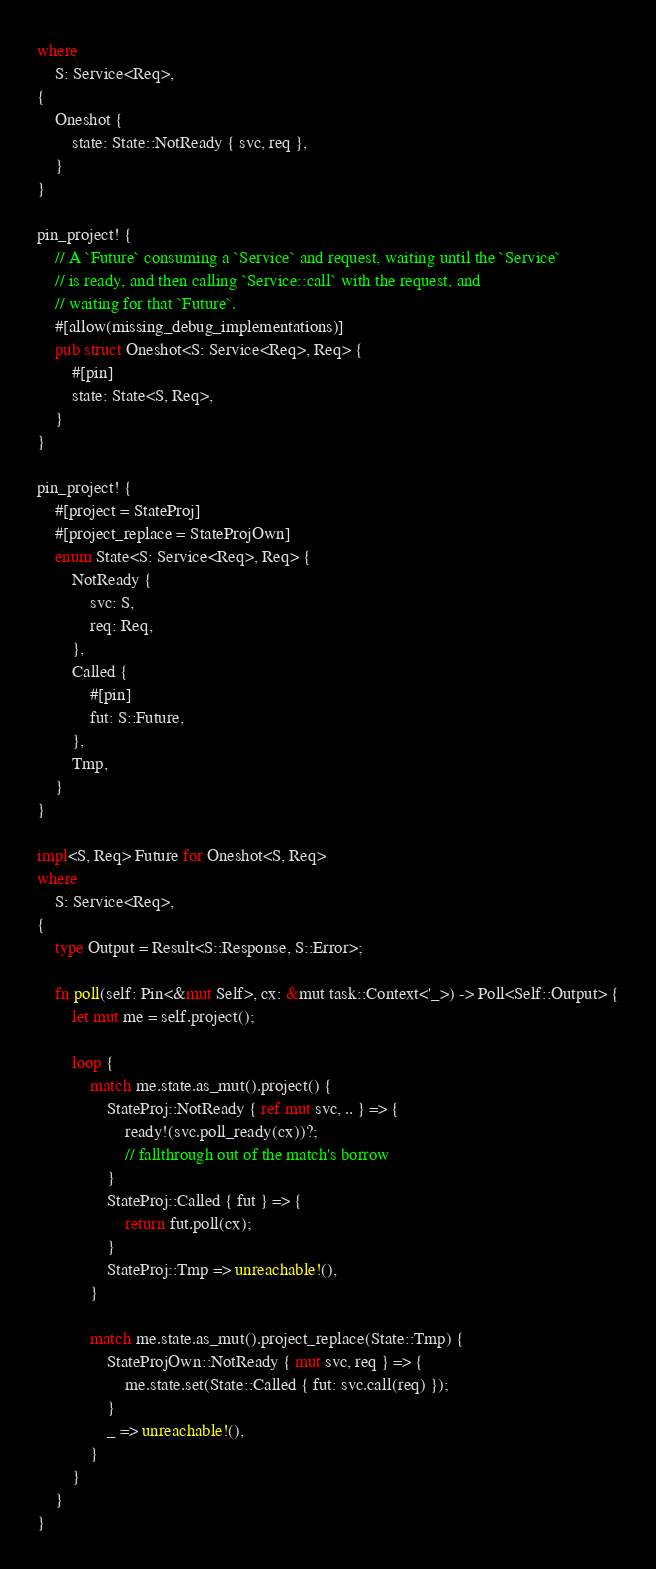<code> <loc_0><loc_0><loc_500><loc_500><_Rust_>where
    S: Service<Req>,
{
    Oneshot {
        state: State::NotReady { svc, req },
    }
}

pin_project! {
    // A `Future` consuming a `Service` and request, waiting until the `Service`
    // is ready, and then calling `Service::call` with the request, and
    // waiting for that `Future`.
    #[allow(missing_debug_implementations)]
    pub struct Oneshot<S: Service<Req>, Req> {
        #[pin]
        state: State<S, Req>,
    }
}

pin_project! {
    #[project = StateProj]
    #[project_replace = StateProjOwn]
    enum State<S: Service<Req>, Req> {
        NotReady {
            svc: S,
            req: Req,
        },
        Called {
            #[pin]
            fut: S::Future,
        },
        Tmp,
    }
}

impl<S, Req> Future for Oneshot<S, Req>
where
    S: Service<Req>,
{
    type Output = Result<S::Response, S::Error>;

    fn poll(self: Pin<&mut Self>, cx: &mut task::Context<'_>) -> Poll<Self::Output> {
        let mut me = self.project();

        loop {
            match me.state.as_mut().project() {
                StateProj::NotReady { ref mut svc, .. } => {
                    ready!(svc.poll_ready(cx))?;
                    // fallthrough out of the match's borrow
                }
                StateProj::Called { fut } => {
                    return fut.poll(cx);
                }
                StateProj::Tmp => unreachable!(),
            }

            match me.state.as_mut().project_replace(State::Tmp) {
                StateProjOwn::NotReady { mut svc, req } => {
                    me.state.set(State::Called { fut: svc.call(req) });
                }
                _ => unreachable!(),
            }
        }
    }
}
</code> 